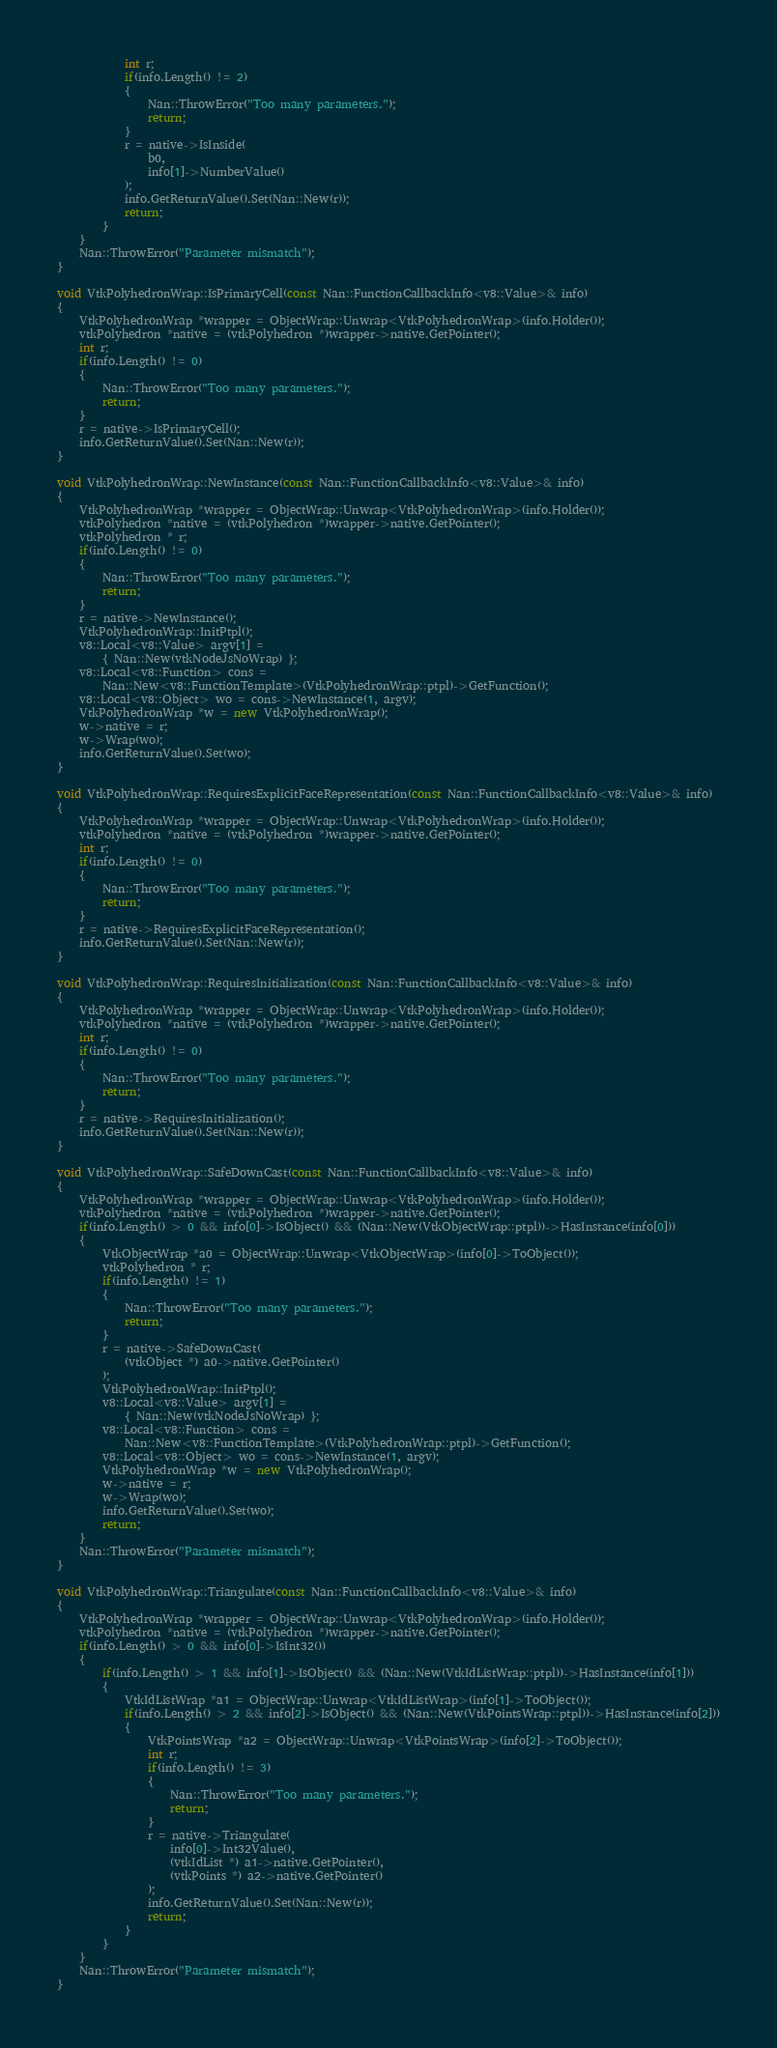<code> <loc_0><loc_0><loc_500><loc_500><_C++_>			int r;
			if(info.Length() != 2)
			{
				Nan::ThrowError("Too many parameters.");
				return;
			}
			r = native->IsInside(
				b0,
				info[1]->NumberValue()
			);
			info.GetReturnValue().Set(Nan::New(r));
			return;
		}
	}
	Nan::ThrowError("Parameter mismatch");
}

void VtkPolyhedronWrap::IsPrimaryCell(const Nan::FunctionCallbackInfo<v8::Value>& info)
{
	VtkPolyhedronWrap *wrapper = ObjectWrap::Unwrap<VtkPolyhedronWrap>(info.Holder());
	vtkPolyhedron *native = (vtkPolyhedron *)wrapper->native.GetPointer();
	int r;
	if(info.Length() != 0)
	{
		Nan::ThrowError("Too many parameters.");
		return;
	}
	r = native->IsPrimaryCell();
	info.GetReturnValue().Set(Nan::New(r));
}

void VtkPolyhedronWrap::NewInstance(const Nan::FunctionCallbackInfo<v8::Value>& info)
{
	VtkPolyhedronWrap *wrapper = ObjectWrap::Unwrap<VtkPolyhedronWrap>(info.Holder());
	vtkPolyhedron *native = (vtkPolyhedron *)wrapper->native.GetPointer();
	vtkPolyhedron * r;
	if(info.Length() != 0)
	{
		Nan::ThrowError("Too many parameters.");
		return;
	}
	r = native->NewInstance();
	VtkPolyhedronWrap::InitPtpl();
	v8::Local<v8::Value> argv[1] =
		{ Nan::New(vtkNodeJsNoWrap) };
	v8::Local<v8::Function> cons =
		Nan::New<v8::FunctionTemplate>(VtkPolyhedronWrap::ptpl)->GetFunction();
	v8::Local<v8::Object> wo = cons->NewInstance(1, argv);
	VtkPolyhedronWrap *w = new VtkPolyhedronWrap();
	w->native = r;
	w->Wrap(wo);
	info.GetReturnValue().Set(wo);
}

void VtkPolyhedronWrap::RequiresExplicitFaceRepresentation(const Nan::FunctionCallbackInfo<v8::Value>& info)
{
	VtkPolyhedronWrap *wrapper = ObjectWrap::Unwrap<VtkPolyhedronWrap>(info.Holder());
	vtkPolyhedron *native = (vtkPolyhedron *)wrapper->native.GetPointer();
	int r;
	if(info.Length() != 0)
	{
		Nan::ThrowError("Too many parameters.");
		return;
	}
	r = native->RequiresExplicitFaceRepresentation();
	info.GetReturnValue().Set(Nan::New(r));
}

void VtkPolyhedronWrap::RequiresInitialization(const Nan::FunctionCallbackInfo<v8::Value>& info)
{
	VtkPolyhedronWrap *wrapper = ObjectWrap::Unwrap<VtkPolyhedronWrap>(info.Holder());
	vtkPolyhedron *native = (vtkPolyhedron *)wrapper->native.GetPointer();
	int r;
	if(info.Length() != 0)
	{
		Nan::ThrowError("Too many parameters.");
		return;
	}
	r = native->RequiresInitialization();
	info.GetReturnValue().Set(Nan::New(r));
}

void VtkPolyhedronWrap::SafeDownCast(const Nan::FunctionCallbackInfo<v8::Value>& info)
{
	VtkPolyhedronWrap *wrapper = ObjectWrap::Unwrap<VtkPolyhedronWrap>(info.Holder());
	vtkPolyhedron *native = (vtkPolyhedron *)wrapper->native.GetPointer();
	if(info.Length() > 0 && info[0]->IsObject() && (Nan::New(VtkObjectWrap::ptpl))->HasInstance(info[0]))
	{
		VtkObjectWrap *a0 = ObjectWrap::Unwrap<VtkObjectWrap>(info[0]->ToObject());
		vtkPolyhedron * r;
		if(info.Length() != 1)
		{
			Nan::ThrowError("Too many parameters.");
			return;
		}
		r = native->SafeDownCast(
			(vtkObject *) a0->native.GetPointer()
		);
		VtkPolyhedronWrap::InitPtpl();
		v8::Local<v8::Value> argv[1] =
			{ Nan::New(vtkNodeJsNoWrap) };
		v8::Local<v8::Function> cons =
			Nan::New<v8::FunctionTemplate>(VtkPolyhedronWrap::ptpl)->GetFunction();
		v8::Local<v8::Object> wo = cons->NewInstance(1, argv);
		VtkPolyhedronWrap *w = new VtkPolyhedronWrap();
		w->native = r;
		w->Wrap(wo);
		info.GetReturnValue().Set(wo);
		return;
	}
	Nan::ThrowError("Parameter mismatch");
}

void VtkPolyhedronWrap::Triangulate(const Nan::FunctionCallbackInfo<v8::Value>& info)
{
	VtkPolyhedronWrap *wrapper = ObjectWrap::Unwrap<VtkPolyhedronWrap>(info.Holder());
	vtkPolyhedron *native = (vtkPolyhedron *)wrapper->native.GetPointer();
	if(info.Length() > 0 && info[0]->IsInt32())
	{
		if(info.Length() > 1 && info[1]->IsObject() && (Nan::New(VtkIdListWrap::ptpl))->HasInstance(info[1]))
		{
			VtkIdListWrap *a1 = ObjectWrap::Unwrap<VtkIdListWrap>(info[1]->ToObject());
			if(info.Length() > 2 && info[2]->IsObject() && (Nan::New(VtkPointsWrap::ptpl))->HasInstance(info[2]))
			{
				VtkPointsWrap *a2 = ObjectWrap::Unwrap<VtkPointsWrap>(info[2]->ToObject());
				int r;
				if(info.Length() != 3)
				{
					Nan::ThrowError("Too many parameters.");
					return;
				}
				r = native->Triangulate(
					info[0]->Int32Value(),
					(vtkIdList *) a1->native.GetPointer(),
					(vtkPoints *) a2->native.GetPointer()
				);
				info.GetReturnValue().Set(Nan::New(r));
				return;
			}
		}
	}
	Nan::ThrowError("Parameter mismatch");
}

</code> 